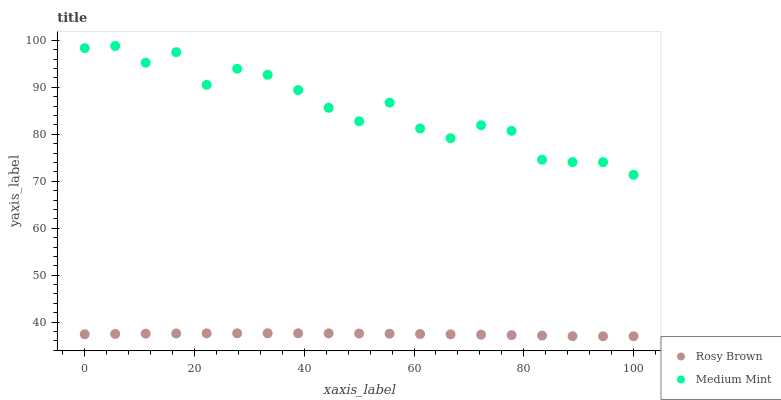Does Rosy Brown have the minimum area under the curve?
Answer yes or no. Yes. Does Medium Mint have the maximum area under the curve?
Answer yes or no. Yes. Does Rosy Brown have the maximum area under the curve?
Answer yes or no. No. Is Rosy Brown the smoothest?
Answer yes or no. Yes. Is Medium Mint the roughest?
Answer yes or no. Yes. Is Rosy Brown the roughest?
Answer yes or no. No. Does Rosy Brown have the lowest value?
Answer yes or no. Yes. Does Medium Mint have the highest value?
Answer yes or no. Yes. Does Rosy Brown have the highest value?
Answer yes or no. No. Is Rosy Brown less than Medium Mint?
Answer yes or no. Yes. Is Medium Mint greater than Rosy Brown?
Answer yes or no. Yes. Does Rosy Brown intersect Medium Mint?
Answer yes or no. No. 